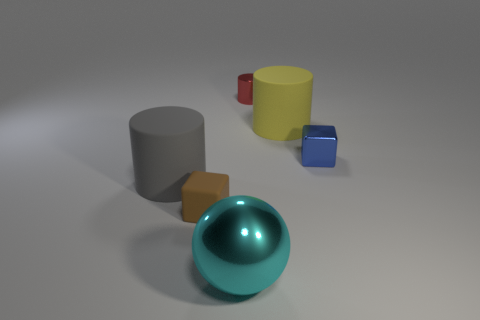What number of big green metallic balls are there?
Make the answer very short. 0. There is a rubber cylinder on the left side of the tiny brown rubber block that is in front of the big cylinder to the right of the cyan object; how big is it?
Keep it short and to the point. Large. Do the tiny metallic cube and the ball have the same color?
Provide a succinct answer. No. Is there any other thing that is the same size as the brown thing?
Ensure brevity in your answer.  Yes. How many big balls are to the right of the tiny blue object?
Provide a succinct answer. 0. Is the number of metallic cubes that are on the left side of the tiny rubber thing the same as the number of rubber blocks?
Your answer should be compact. No. What number of objects are large things or tiny green rubber balls?
Offer a terse response. 3. Are there any other things that have the same shape as the red object?
Offer a terse response. Yes. What is the shape of the big thing that is left of the small object that is in front of the blue block?
Your response must be concise. Cylinder. What is the shape of the red object that is the same material as the small blue thing?
Ensure brevity in your answer.  Cylinder. 